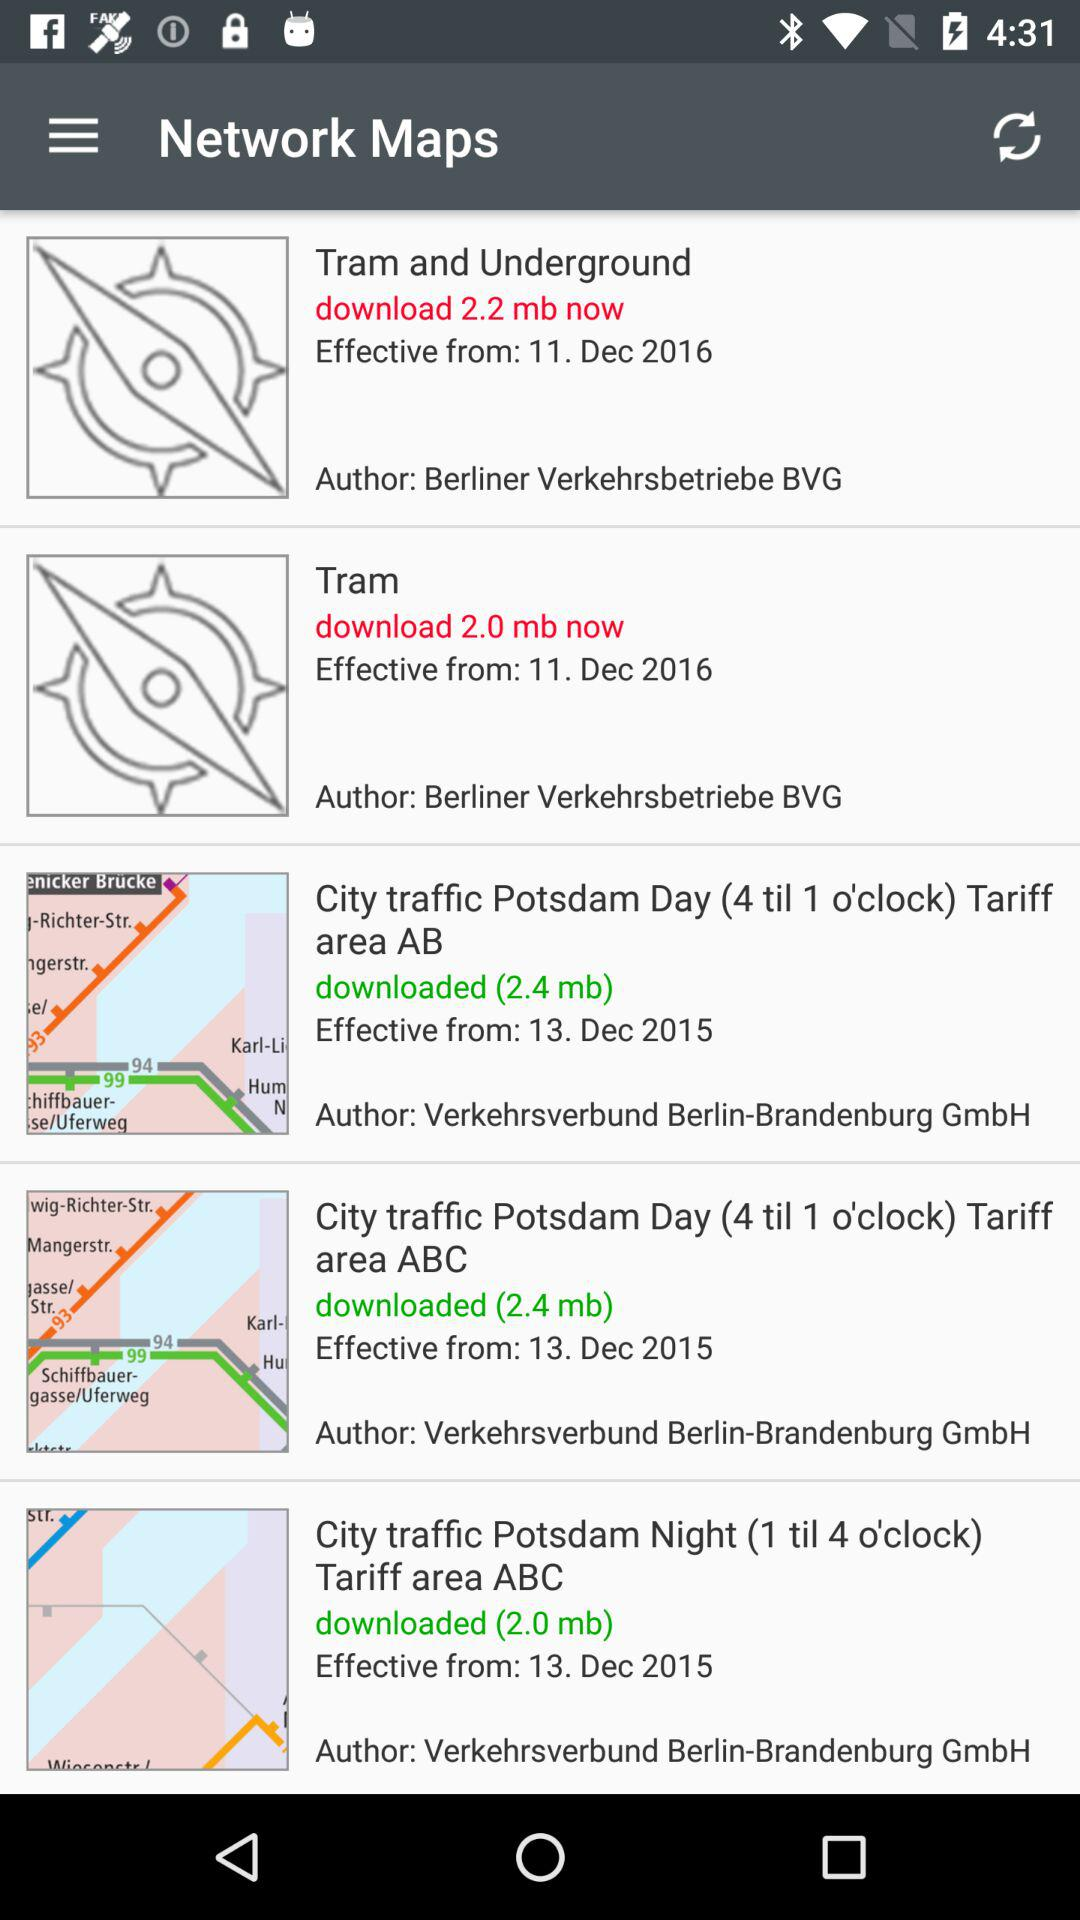Who is the author of "City traffic Potsdam night (1 till 4 o'clock) Tariff area ABC"? The author is Verkehrsverbund Berlin-Brandenburg GmbH. 